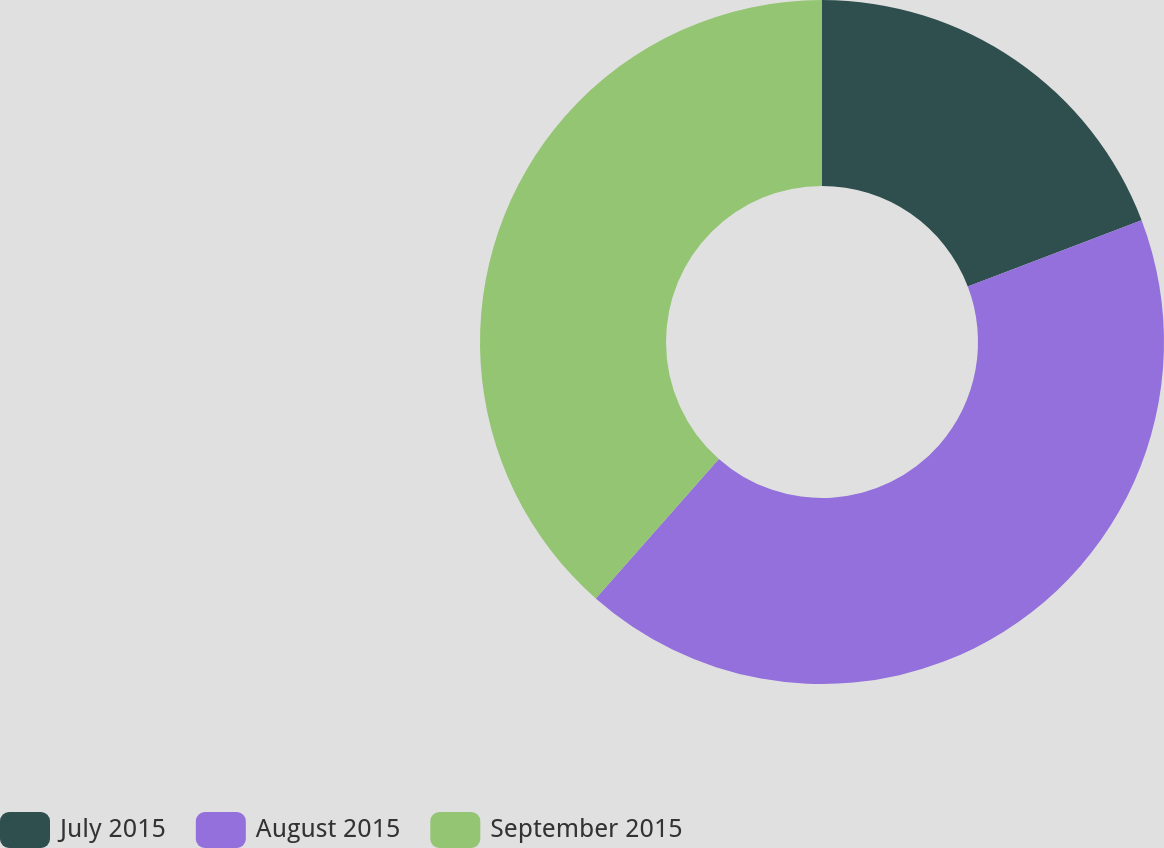Convert chart to OTSL. <chart><loc_0><loc_0><loc_500><loc_500><pie_chart><fcel>July 2015<fcel>August 2015<fcel>September 2015<nl><fcel>19.21%<fcel>42.3%<fcel>38.5%<nl></chart> 